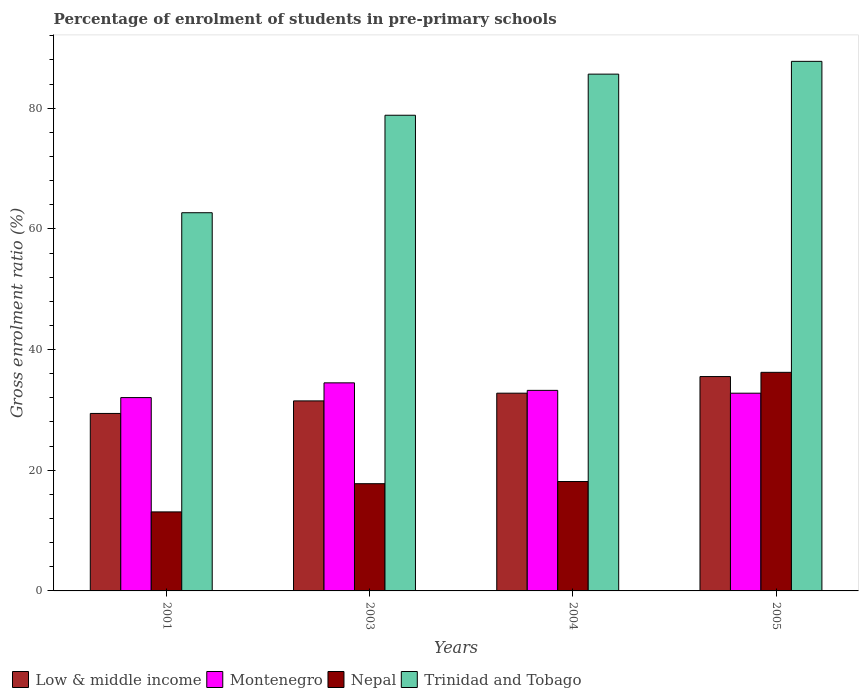How many different coloured bars are there?
Your answer should be compact. 4. How many groups of bars are there?
Provide a succinct answer. 4. Are the number of bars on each tick of the X-axis equal?
Ensure brevity in your answer.  Yes. What is the label of the 2nd group of bars from the left?
Give a very brief answer. 2003. In how many cases, is the number of bars for a given year not equal to the number of legend labels?
Make the answer very short. 0. What is the percentage of students enrolled in pre-primary schools in Montenegro in 2001?
Ensure brevity in your answer.  32.04. Across all years, what is the maximum percentage of students enrolled in pre-primary schools in Low & middle income?
Your answer should be very brief. 35.53. Across all years, what is the minimum percentage of students enrolled in pre-primary schools in Nepal?
Your answer should be very brief. 13.1. In which year was the percentage of students enrolled in pre-primary schools in Low & middle income minimum?
Provide a short and direct response. 2001. What is the total percentage of students enrolled in pre-primary schools in Trinidad and Tobago in the graph?
Offer a terse response. 314.93. What is the difference between the percentage of students enrolled in pre-primary schools in Low & middle income in 2004 and that in 2005?
Make the answer very short. -2.76. What is the difference between the percentage of students enrolled in pre-primary schools in Nepal in 2003 and the percentage of students enrolled in pre-primary schools in Trinidad and Tobago in 2005?
Your answer should be compact. -70. What is the average percentage of students enrolled in pre-primary schools in Trinidad and Tobago per year?
Provide a short and direct response. 78.73. In the year 2003, what is the difference between the percentage of students enrolled in pre-primary schools in Trinidad and Tobago and percentage of students enrolled in pre-primary schools in Montenegro?
Your response must be concise. 44.35. In how many years, is the percentage of students enrolled in pre-primary schools in Low & middle income greater than 56 %?
Make the answer very short. 0. What is the ratio of the percentage of students enrolled in pre-primary schools in Trinidad and Tobago in 2001 to that in 2004?
Offer a very short reply. 0.73. Is the difference between the percentage of students enrolled in pre-primary schools in Trinidad and Tobago in 2004 and 2005 greater than the difference between the percentage of students enrolled in pre-primary schools in Montenegro in 2004 and 2005?
Provide a succinct answer. No. What is the difference between the highest and the second highest percentage of students enrolled in pre-primary schools in Trinidad and Tobago?
Offer a terse response. 2.12. What is the difference between the highest and the lowest percentage of students enrolled in pre-primary schools in Trinidad and Tobago?
Your answer should be compact. 25.09. In how many years, is the percentage of students enrolled in pre-primary schools in Nepal greater than the average percentage of students enrolled in pre-primary schools in Nepal taken over all years?
Your answer should be compact. 1. What does the 2nd bar from the left in 2003 represents?
Offer a terse response. Montenegro. What does the 2nd bar from the right in 2005 represents?
Ensure brevity in your answer.  Nepal. Is it the case that in every year, the sum of the percentage of students enrolled in pre-primary schools in Montenegro and percentage of students enrolled in pre-primary schools in Low & middle income is greater than the percentage of students enrolled in pre-primary schools in Trinidad and Tobago?
Ensure brevity in your answer.  No. How many bars are there?
Provide a short and direct response. 16. Are all the bars in the graph horizontal?
Keep it short and to the point. No. What is the difference between two consecutive major ticks on the Y-axis?
Give a very brief answer. 20. Where does the legend appear in the graph?
Ensure brevity in your answer.  Bottom left. How many legend labels are there?
Offer a terse response. 4. What is the title of the graph?
Offer a very short reply. Percentage of enrolment of students in pre-primary schools. What is the label or title of the Y-axis?
Give a very brief answer. Gross enrolment ratio (%). What is the Gross enrolment ratio (%) of Low & middle income in 2001?
Keep it short and to the point. 29.41. What is the Gross enrolment ratio (%) of Montenegro in 2001?
Ensure brevity in your answer.  32.04. What is the Gross enrolment ratio (%) in Nepal in 2001?
Make the answer very short. 13.1. What is the Gross enrolment ratio (%) in Trinidad and Tobago in 2001?
Provide a short and direct response. 62.68. What is the Gross enrolment ratio (%) in Low & middle income in 2003?
Ensure brevity in your answer.  31.49. What is the Gross enrolment ratio (%) of Montenegro in 2003?
Make the answer very short. 34.48. What is the Gross enrolment ratio (%) in Nepal in 2003?
Offer a terse response. 17.77. What is the Gross enrolment ratio (%) of Trinidad and Tobago in 2003?
Make the answer very short. 78.84. What is the Gross enrolment ratio (%) of Low & middle income in 2004?
Give a very brief answer. 32.77. What is the Gross enrolment ratio (%) of Montenegro in 2004?
Your response must be concise. 33.24. What is the Gross enrolment ratio (%) in Nepal in 2004?
Provide a succinct answer. 18.13. What is the Gross enrolment ratio (%) of Trinidad and Tobago in 2004?
Offer a very short reply. 85.65. What is the Gross enrolment ratio (%) of Low & middle income in 2005?
Make the answer very short. 35.53. What is the Gross enrolment ratio (%) of Montenegro in 2005?
Ensure brevity in your answer.  32.77. What is the Gross enrolment ratio (%) in Nepal in 2005?
Offer a very short reply. 36.23. What is the Gross enrolment ratio (%) in Trinidad and Tobago in 2005?
Your answer should be very brief. 87.77. Across all years, what is the maximum Gross enrolment ratio (%) of Low & middle income?
Offer a terse response. 35.53. Across all years, what is the maximum Gross enrolment ratio (%) in Montenegro?
Your answer should be very brief. 34.48. Across all years, what is the maximum Gross enrolment ratio (%) in Nepal?
Your response must be concise. 36.23. Across all years, what is the maximum Gross enrolment ratio (%) in Trinidad and Tobago?
Your answer should be very brief. 87.77. Across all years, what is the minimum Gross enrolment ratio (%) of Low & middle income?
Your response must be concise. 29.41. Across all years, what is the minimum Gross enrolment ratio (%) in Montenegro?
Your answer should be compact. 32.04. Across all years, what is the minimum Gross enrolment ratio (%) of Nepal?
Offer a very short reply. 13.1. Across all years, what is the minimum Gross enrolment ratio (%) in Trinidad and Tobago?
Your answer should be very brief. 62.68. What is the total Gross enrolment ratio (%) of Low & middle income in the graph?
Provide a short and direct response. 129.21. What is the total Gross enrolment ratio (%) in Montenegro in the graph?
Offer a terse response. 132.54. What is the total Gross enrolment ratio (%) of Nepal in the graph?
Offer a terse response. 85.22. What is the total Gross enrolment ratio (%) of Trinidad and Tobago in the graph?
Make the answer very short. 314.93. What is the difference between the Gross enrolment ratio (%) in Low & middle income in 2001 and that in 2003?
Your answer should be very brief. -2.08. What is the difference between the Gross enrolment ratio (%) in Montenegro in 2001 and that in 2003?
Your response must be concise. -2.44. What is the difference between the Gross enrolment ratio (%) of Nepal in 2001 and that in 2003?
Offer a very short reply. -4.67. What is the difference between the Gross enrolment ratio (%) in Trinidad and Tobago in 2001 and that in 2003?
Offer a terse response. -16.16. What is the difference between the Gross enrolment ratio (%) in Low & middle income in 2001 and that in 2004?
Give a very brief answer. -3.36. What is the difference between the Gross enrolment ratio (%) in Montenegro in 2001 and that in 2004?
Your answer should be very brief. -1.2. What is the difference between the Gross enrolment ratio (%) in Nepal in 2001 and that in 2004?
Provide a short and direct response. -5.04. What is the difference between the Gross enrolment ratio (%) of Trinidad and Tobago in 2001 and that in 2004?
Offer a terse response. -22.97. What is the difference between the Gross enrolment ratio (%) of Low & middle income in 2001 and that in 2005?
Your answer should be very brief. -6.11. What is the difference between the Gross enrolment ratio (%) of Montenegro in 2001 and that in 2005?
Provide a short and direct response. -0.73. What is the difference between the Gross enrolment ratio (%) of Nepal in 2001 and that in 2005?
Offer a very short reply. -23.13. What is the difference between the Gross enrolment ratio (%) in Trinidad and Tobago in 2001 and that in 2005?
Make the answer very short. -25.09. What is the difference between the Gross enrolment ratio (%) of Low & middle income in 2003 and that in 2004?
Your response must be concise. -1.28. What is the difference between the Gross enrolment ratio (%) in Montenegro in 2003 and that in 2004?
Offer a terse response. 1.25. What is the difference between the Gross enrolment ratio (%) in Nepal in 2003 and that in 2004?
Your response must be concise. -0.36. What is the difference between the Gross enrolment ratio (%) of Trinidad and Tobago in 2003 and that in 2004?
Make the answer very short. -6.81. What is the difference between the Gross enrolment ratio (%) in Low & middle income in 2003 and that in 2005?
Provide a short and direct response. -4.04. What is the difference between the Gross enrolment ratio (%) of Montenegro in 2003 and that in 2005?
Provide a succinct answer. 1.71. What is the difference between the Gross enrolment ratio (%) of Nepal in 2003 and that in 2005?
Provide a short and direct response. -18.46. What is the difference between the Gross enrolment ratio (%) in Trinidad and Tobago in 2003 and that in 2005?
Offer a very short reply. -8.93. What is the difference between the Gross enrolment ratio (%) of Low & middle income in 2004 and that in 2005?
Ensure brevity in your answer.  -2.76. What is the difference between the Gross enrolment ratio (%) in Montenegro in 2004 and that in 2005?
Ensure brevity in your answer.  0.47. What is the difference between the Gross enrolment ratio (%) of Nepal in 2004 and that in 2005?
Your response must be concise. -18.1. What is the difference between the Gross enrolment ratio (%) in Trinidad and Tobago in 2004 and that in 2005?
Offer a terse response. -2.12. What is the difference between the Gross enrolment ratio (%) of Low & middle income in 2001 and the Gross enrolment ratio (%) of Montenegro in 2003?
Your answer should be compact. -5.07. What is the difference between the Gross enrolment ratio (%) in Low & middle income in 2001 and the Gross enrolment ratio (%) in Nepal in 2003?
Offer a terse response. 11.64. What is the difference between the Gross enrolment ratio (%) of Low & middle income in 2001 and the Gross enrolment ratio (%) of Trinidad and Tobago in 2003?
Offer a very short reply. -49.42. What is the difference between the Gross enrolment ratio (%) in Montenegro in 2001 and the Gross enrolment ratio (%) in Nepal in 2003?
Provide a succinct answer. 14.27. What is the difference between the Gross enrolment ratio (%) of Montenegro in 2001 and the Gross enrolment ratio (%) of Trinidad and Tobago in 2003?
Your response must be concise. -46.8. What is the difference between the Gross enrolment ratio (%) of Nepal in 2001 and the Gross enrolment ratio (%) of Trinidad and Tobago in 2003?
Ensure brevity in your answer.  -65.74. What is the difference between the Gross enrolment ratio (%) of Low & middle income in 2001 and the Gross enrolment ratio (%) of Montenegro in 2004?
Your response must be concise. -3.82. What is the difference between the Gross enrolment ratio (%) of Low & middle income in 2001 and the Gross enrolment ratio (%) of Nepal in 2004?
Give a very brief answer. 11.28. What is the difference between the Gross enrolment ratio (%) of Low & middle income in 2001 and the Gross enrolment ratio (%) of Trinidad and Tobago in 2004?
Offer a terse response. -56.23. What is the difference between the Gross enrolment ratio (%) in Montenegro in 2001 and the Gross enrolment ratio (%) in Nepal in 2004?
Ensure brevity in your answer.  13.91. What is the difference between the Gross enrolment ratio (%) of Montenegro in 2001 and the Gross enrolment ratio (%) of Trinidad and Tobago in 2004?
Offer a very short reply. -53.61. What is the difference between the Gross enrolment ratio (%) of Nepal in 2001 and the Gross enrolment ratio (%) of Trinidad and Tobago in 2004?
Offer a very short reply. -72.55. What is the difference between the Gross enrolment ratio (%) in Low & middle income in 2001 and the Gross enrolment ratio (%) in Montenegro in 2005?
Your answer should be compact. -3.36. What is the difference between the Gross enrolment ratio (%) of Low & middle income in 2001 and the Gross enrolment ratio (%) of Nepal in 2005?
Offer a very short reply. -6.81. What is the difference between the Gross enrolment ratio (%) in Low & middle income in 2001 and the Gross enrolment ratio (%) in Trinidad and Tobago in 2005?
Your response must be concise. -58.35. What is the difference between the Gross enrolment ratio (%) in Montenegro in 2001 and the Gross enrolment ratio (%) in Nepal in 2005?
Offer a very short reply. -4.19. What is the difference between the Gross enrolment ratio (%) in Montenegro in 2001 and the Gross enrolment ratio (%) in Trinidad and Tobago in 2005?
Provide a short and direct response. -55.73. What is the difference between the Gross enrolment ratio (%) of Nepal in 2001 and the Gross enrolment ratio (%) of Trinidad and Tobago in 2005?
Give a very brief answer. -74.67. What is the difference between the Gross enrolment ratio (%) of Low & middle income in 2003 and the Gross enrolment ratio (%) of Montenegro in 2004?
Keep it short and to the point. -1.75. What is the difference between the Gross enrolment ratio (%) of Low & middle income in 2003 and the Gross enrolment ratio (%) of Nepal in 2004?
Ensure brevity in your answer.  13.36. What is the difference between the Gross enrolment ratio (%) in Low & middle income in 2003 and the Gross enrolment ratio (%) in Trinidad and Tobago in 2004?
Provide a succinct answer. -54.16. What is the difference between the Gross enrolment ratio (%) of Montenegro in 2003 and the Gross enrolment ratio (%) of Nepal in 2004?
Keep it short and to the point. 16.35. What is the difference between the Gross enrolment ratio (%) of Montenegro in 2003 and the Gross enrolment ratio (%) of Trinidad and Tobago in 2004?
Keep it short and to the point. -51.16. What is the difference between the Gross enrolment ratio (%) of Nepal in 2003 and the Gross enrolment ratio (%) of Trinidad and Tobago in 2004?
Your answer should be compact. -67.88. What is the difference between the Gross enrolment ratio (%) of Low & middle income in 2003 and the Gross enrolment ratio (%) of Montenegro in 2005?
Your answer should be compact. -1.28. What is the difference between the Gross enrolment ratio (%) of Low & middle income in 2003 and the Gross enrolment ratio (%) of Nepal in 2005?
Offer a terse response. -4.73. What is the difference between the Gross enrolment ratio (%) in Low & middle income in 2003 and the Gross enrolment ratio (%) in Trinidad and Tobago in 2005?
Ensure brevity in your answer.  -56.27. What is the difference between the Gross enrolment ratio (%) in Montenegro in 2003 and the Gross enrolment ratio (%) in Nepal in 2005?
Keep it short and to the point. -1.74. What is the difference between the Gross enrolment ratio (%) of Montenegro in 2003 and the Gross enrolment ratio (%) of Trinidad and Tobago in 2005?
Your answer should be very brief. -53.28. What is the difference between the Gross enrolment ratio (%) of Nepal in 2003 and the Gross enrolment ratio (%) of Trinidad and Tobago in 2005?
Ensure brevity in your answer.  -70. What is the difference between the Gross enrolment ratio (%) of Low & middle income in 2004 and the Gross enrolment ratio (%) of Montenegro in 2005?
Offer a very short reply. 0. What is the difference between the Gross enrolment ratio (%) of Low & middle income in 2004 and the Gross enrolment ratio (%) of Nepal in 2005?
Your response must be concise. -3.45. What is the difference between the Gross enrolment ratio (%) in Low & middle income in 2004 and the Gross enrolment ratio (%) in Trinidad and Tobago in 2005?
Offer a terse response. -54.99. What is the difference between the Gross enrolment ratio (%) of Montenegro in 2004 and the Gross enrolment ratio (%) of Nepal in 2005?
Your response must be concise. -2.99. What is the difference between the Gross enrolment ratio (%) of Montenegro in 2004 and the Gross enrolment ratio (%) of Trinidad and Tobago in 2005?
Provide a short and direct response. -54.53. What is the difference between the Gross enrolment ratio (%) of Nepal in 2004 and the Gross enrolment ratio (%) of Trinidad and Tobago in 2005?
Make the answer very short. -69.64. What is the average Gross enrolment ratio (%) in Low & middle income per year?
Give a very brief answer. 32.3. What is the average Gross enrolment ratio (%) in Montenegro per year?
Your answer should be very brief. 33.13. What is the average Gross enrolment ratio (%) in Nepal per year?
Make the answer very short. 21.31. What is the average Gross enrolment ratio (%) in Trinidad and Tobago per year?
Make the answer very short. 78.73. In the year 2001, what is the difference between the Gross enrolment ratio (%) in Low & middle income and Gross enrolment ratio (%) in Montenegro?
Your answer should be very brief. -2.63. In the year 2001, what is the difference between the Gross enrolment ratio (%) in Low & middle income and Gross enrolment ratio (%) in Nepal?
Give a very brief answer. 16.32. In the year 2001, what is the difference between the Gross enrolment ratio (%) of Low & middle income and Gross enrolment ratio (%) of Trinidad and Tobago?
Make the answer very short. -33.26. In the year 2001, what is the difference between the Gross enrolment ratio (%) in Montenegro and Gross enrolment ratio (%) in Nepal?
Offer a very short reply. 18.95. In the year 2001, what is the difference between the Gross enrolment ratio (%) in Montenegro and Gross enrolment ratio (%) in Trinidad and Tobago?
Provide a short and direct response. -30.64. In the year 2001, what is the difference between the Gross enrolment ratio (%) in Nepal and Gross enrolment ratio (%) in Trinidad and Tobago?
Ensure brevity in your answer.  -49.58. In the year 2003, what is the difference between the Gross enrolment ratio (%) in Low & middle income and Gross enrolment ratio (%) in Montenegro?
Your answer should be very brief. -2.99. In the year 2003, what is the difference between the Gross enrolment ratio (%) in Low & middle income and Gross enrolment ratio (%) in Nepal?
Offer a terse response. 13.72. In the year 2003, what is the difference between the Gross enrolment ratio (%) of Low & middle income and Gross enrolment ratio (%) of Trinidad and Tobago?
Give a very brief answer. -47.34. In the year 2003, what is the difference between the Gross enrolment ratio (%) of Montenegro and Gross enrolment ratio (%) of Nepal?
Keep it short and to the point. 16.71. In the year 2003, what is the difference between the Gross enrolment ratio (%) in Montenegro and Gross enrolment ratio (%) in Trinidad and Tobago?
Keep it short and to the point. -44.35. In the year 2003, what is the difference between the Gross enrolment ratio (%) of Nepal and Gross enrolment ratio (%) of Trinidad and Tobago?
Your response must be concise. -61.07. In the year 2004, what is the difference between the Gross enrolment ratio (%) in Low & middle income and Gross enrolment ratio (%) in Montenegro?
Your response must be concise. -0.47. In the year 2004, what is the difference between the Gross enrolment ratio (%) of Low & middle income and Gross enrolment ratio (%) of Nepal?
Ensure brevity in your answer.  14.64. In the year 2004, what is the difference between the Gross enrolment ratio (%) in Low & middle income and Gross enrolment ratio (%) in Trinidad and Tobago?
Offer a terse response. -52.88. In the year 2004, what is the difference between the Gross enrolment ratio (%) in Montenegro and Gross enrolment ratio (%) in Nepal?
Keep it short and to the point. 15.11. In the year 2004, what is the difference between the Gross enrolment ratio (%) of Montenegro and Gross enrolment ratio (%) of Trinidad and Tobago?
Ensure brevity in your answer.  -52.41. In the year 2004, what is the difference between the Gross enrolment ratio (%) in Nepal and Gross enrolment ratio (%) in Trinidad and Tobago?
Keep it short and to the point. -67.52. In the year 2005, what is the difference between the Gross enrolment ratio (%) in Low & middle income and Gross enrolment ratio (%) in Montenegro?
Ensure brevity in your answer.  2.76. In the year 2005, what is the difference between the Gross enrolment ratio (%) of Low & middle income and Gross enrolment ratio (%) of Nepal?
Provide a succinct answer. -0.7. In the year 2005, what is the difference between the Gross enrolment ratio (%) of Low & middle income and Gross enrolment ratio (%) of Trinidad and Tobago?
Ensure brevity in your answer.  -52.24. In the year 2005, what is the difference between the Gross enrolment ratio (%) of Montenegro and Gross enrolment ratio (%) of Nepal?
Ensure brevity in your answer.  -3.46. In the year 2005, what is the difference between the Gross enrolment ratio (%) of Montenegro and Gross enrolment ratio (%) of Trinidad and Tobago?
Make the answer very short. -55. In the year 2005, what is the difference between the Gross enrolment ratio (%) of Nepal and Gross enrolment ratio (%) of Trinidad and Tobago?
Provide a short and direct response. -51.54. What is the ratio of the Gross enrolment ratio (%) in Low & middle income in 2001 to that in 2003?
Your answer should be compact. 0.93. What is the ratio of the Gross enrolment ratio (%) in Montenegro in 2001 to that in 2003?
Offer a terse response. 0.93. What is the ratio of the Gross enrolment ratio (%) in Nepal in 2001 to that in 2003?
Make the answer very short. 0.74. What is the ratio of the Gross enrolment ratio (%) of Trinidad and Tobago in 2001 to that in 2003?
Give a very brief answer. 0.8. What is the ratio of the Gross enrolment ratio (%) in Low & middle income in 2001 to that in 2004?
Give a very brief answer. 0.9. What is the ratio of the Gross enrolment ratio (%) of Nepal in 2001 to that in 2004?
Offer a terse response. 0.72. What is the ratio of the Gross enrolment ratio (%) in Trinidad and Tobago in 2001 to that in 2004?
Your answer should be very brief. 0.73. What is the ratio of the Gross enrolment ratio (%) of Low & middle income in 2001 to that in 2005?
Your answer should be very brief. 0.83. What is the ratio of the Gross enrolment ratio (%) in Montenegro in 2001 to that in 2005?
Provide a succinct answer. 0.98. What is the ratio of the Gross enrolment ratio (%) of Nepal in 2001 to that in 2005?
Offer a terse response. 0.36. What is the ratio of the Gross enrolment ratio (%) in Trinidad and Tobago in 2001 to that in 2005?
Your response must be concise. 0.71. What is the ratio of the Gross enrolment ratio (%) of Low & middle income in 2003 to that in 2004?
Your answer should be compact. 0.96. What is the ratio of the Gross enrolment ratio (%) of Montenegro in 2003 to that in 2004?
Keep it short and to the point. 1.04. What is the ratio of the Gross enrolment ratio (%) of Nepal in 2003 to that in 2004?
Provide a succinct answer. 0.98. What is the ratio of the Gross enrolment ratio (%) of Trinidad and Tobago in 2003 to that in 2004?
Give a very brief answer. 0.92. What is the ratio of the Gross enrolment ratio (%) in Low & middle income in 2003 to that in 2005?
Your answer should be very brief. 0.89. What is the ratio of the Gross enrolment ratio (%) in Montenegro in 2003 to that in 2005?
Your response must be concise. 1.05. What is the ratio of the Gross enrolment ratio (%) in Nepal in 2003 to that in 2005?
Offer a very short reply. 0.49. What is the ratio of the Gross enrolment ratio (%) in Trinidad and Tobago in 2003 to that in 2005?
Make the answer very short. 0.9. What is the ratio of the Gross enrolment ratio (%) of Low & middle income in 2004 to that in 2005?
Offer a very short reply. 0.92. What is the ratio of the Gross enrolment ratio (%) in Montenegro in 2004 to that in 2005?
Provide a succinct answer. 1.01. What is the ratio of the Gross enrolment ratio (%) in Nepal in 2004 to that in 2005?
Offer a very short reply. 0.5. What is the ratio of the Gross enrolment ratio (%) in Trinidad and Tobago in 2004 to that in 2005?
Make the answer very short. 0.98. What is the difference between the highest and the second highest Gross enrolment ratio (%) of Low & middle income?
Make the answer very short. 2.76. What is the difference between the highest and the second highest Gross enrolment ratio (%) in Montenegro?
Make the answer very short. 1.25. What is the difference between the highest and the second highest Gross enrolment ratio (%) of Nepal?
Your response must be concise. 18.1. What is the difference between the highest and the second highest Gross enrolment ratio (%) in Trinidad and Tobago?
Offer a terse response. 2.12. What is the difference between the highest and the lowest Gross enrolment ratio (%) in Low & middle income?
Your response must be concise. 6.11. What is the difference between the highest and the lowest Gross enrolment ratio (%) of Montenegro?
Provide a short and direct response. 2.44. What is the difference between the highest and the lowest Gross enrolment ratio (%) in Nepal?
Your answer should be compact. 23.13. What is the difference between the highest and the lowest Gross enrolment ratio (%) of Trinidad and Tobago?
Keep it short and to the point. 25.09. 